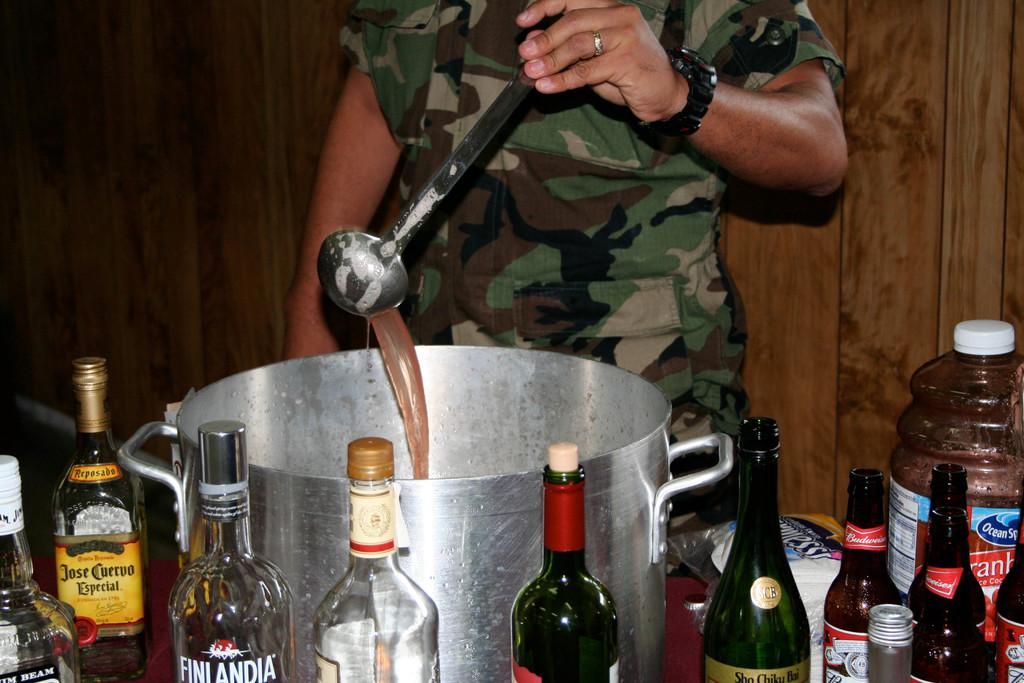Who is present in the image? There is a man in the image. What is the man holding in the image? The man is holding a spoon. What objects can be seen on the table in the image? There are bottles on a table in the image. What type of wall can be seen in the background of the image? There is a wooden wall in the background of the image. Where is the pear located in the image? There is no pear present in the image. Can you describe the kitty's behavior in the image? There is no kitty present in the image. 